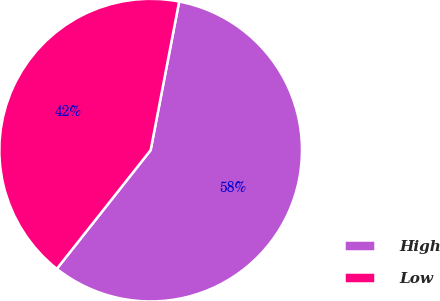Convert chart to OTSL. <chart><loc_0><loc_0><loc_500><loc_500><pie_chart><fcel>High<fcel>Low<nl><fcel>57.63%<fcel>42.37%<nl></chart> 